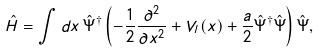Convert formula to latex. <formula><loc_0><loc_0><loc_500><loc_500>\hat { H } = \int d x \, \hat { \Psi } ^ { \dag } \left ( - \frac { 1 } { 2 } \frac { \partial ^ { 2 } } { \partial x ^ { 2 } } + V _ { l } ( x ) + \frac { a } { 2 } \hat { \Psi } ^ { \dag } \hat { \Psi } \right ) \hat { \Psi } ,</formula> 